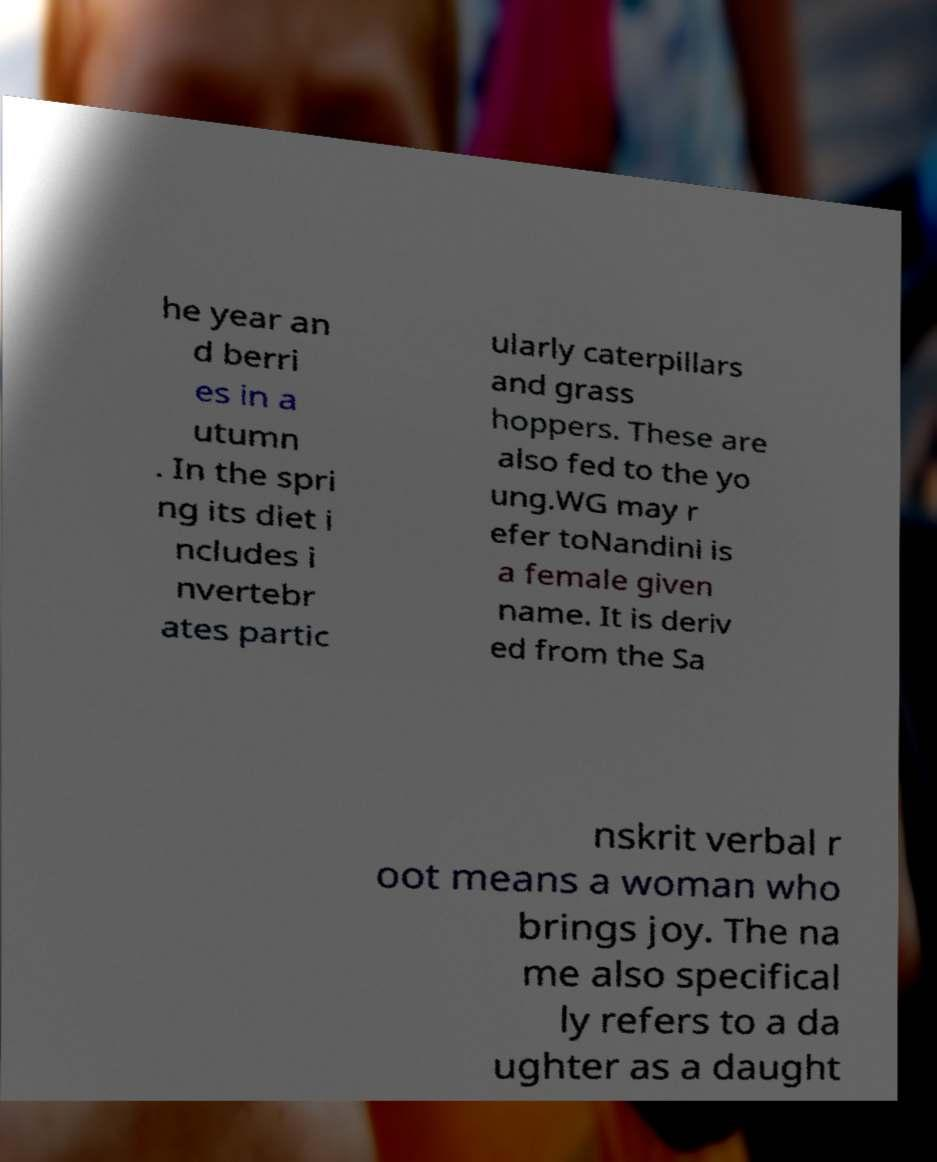I need the written content from this picture converted into text. Can you do that? he year an d berri es in a utumn . In the spri ng its diet i ncludes i nvertebr ates partic ularly caterpillars and grass hoppers. These are also fed to the yo ung.WG may r efer toNandini is a female given name. It is deriv ed from the Sa nskrit verbal r oot means a woman who brings joy. The na me also specifical ly refers to a da ughter as a daught 